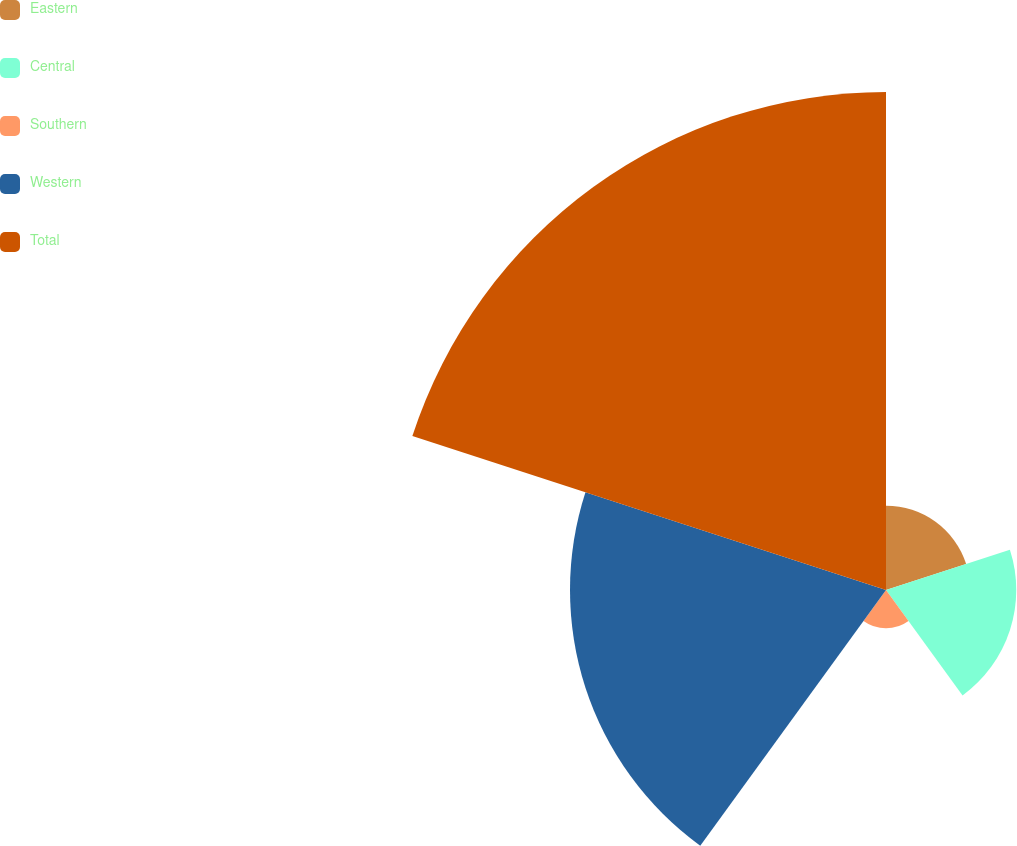Convert chart. <chart><loc_0><loc_0><loc_500><loc_500><pie_chart><fcel>Eastern<fcel>Central<fcel>Southern<fcel>Western<fcel>Total<nl><fcel>7.9%<fcel>12.21%<fcel>3.59%<fcel>29.62%<fcel>46.68%<nl></chart> 